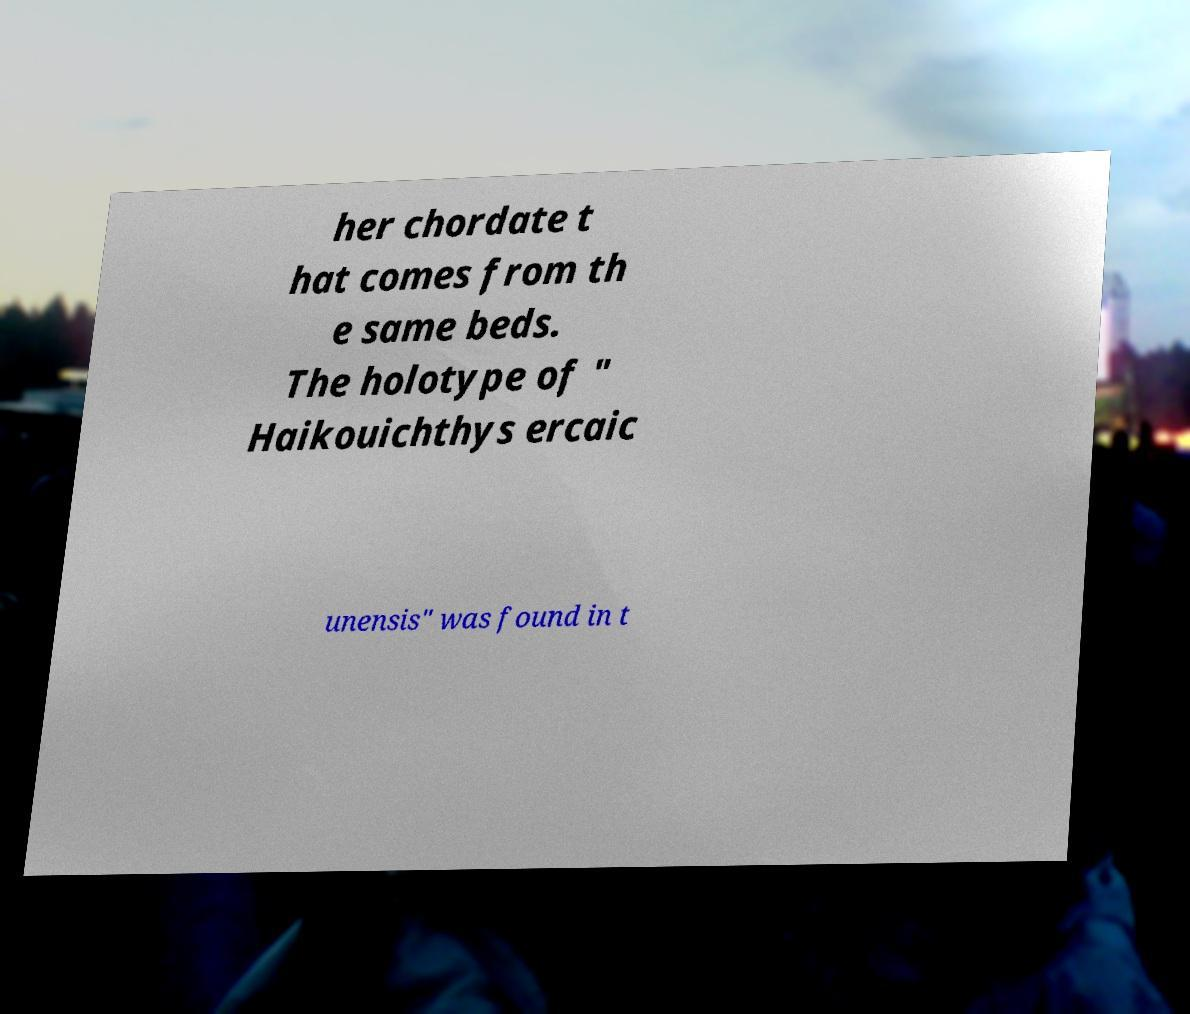Can you accurately transcribe the text from the provided image for me? her chordate t hat comes from th e same beds. The holotype of " Haikouichthys ercaic unensis" was found in t 